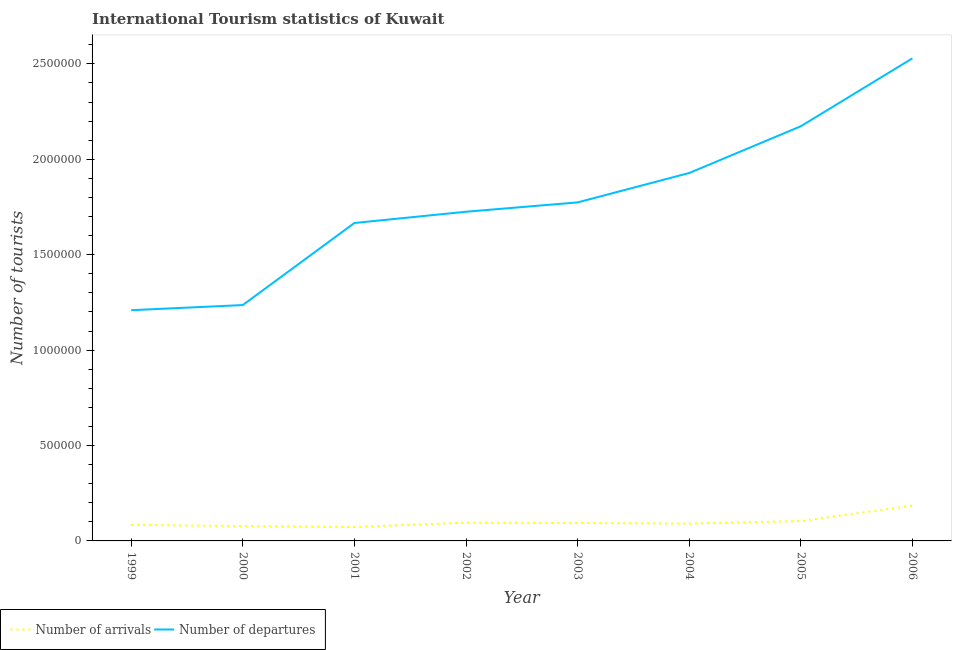How many different coloured lines are there?
Ensure brevity in your answer.  2. Does the line corresponding to number of tourist arrivals intersect with the line corresponding to number of tourist departures?
Your answer should be compact. No. What is the number of tourist arrivals in 1999?
Offer a terse response. 8.40e+04. Across all years, what is the maximum number of tourist departures?
Offer a terse response. 2.53e+06. Across all years, what is the minimum number of tourist departures?
Keep it short and to the point. 1.21e+06. In which year was the number of tourist arrivals maximum?
Provide a short and direct response. 2006. What is the total number of tourist departures in the graph?
Offer a terse response. 1.42e+07. What is the difference between the number of tourist departures in 2002 and that in 2005?
Give a very brief answer. -4.48e+05. What is the difference between the number of tourist arrivals in 2003 and the number of tourist departures in 2000?
Offer a terse response. -1.14e+06. What is the average number of tourist arrivals per year?
Your answer should be very brief. 1.01e+05. In the year 2002, what is the difference between the number of tourist departures and number of tourist arrivals?
Your answer should be compact. 1.63e+06. What is the ratio of the number of tourist departures in 1999 to that in 2005?
Your response must be concise. 0.56. Is the number of tourist departures in 2005 less than that in 2006?
Ensure brevity in your answer.  Yes. What is the difference between the highest and the second highest number of tourist departures?
Provide a succinct answer. 3.56e+05. What is the difference between the highest and the lowest number of tourist departures?
Offer a terse response. 1.32e+06. Is the sum of the number of tourist departures in 2000 and 2006 greater than the maximum number of tourist arrivals across all years?
Provide a succinct answer. Yes. Is the number of tourist departures strictly greater than the number of tourist arrivals over the years?
Make the answer very short. Yes. How many lines are there?
Ensure brevity in your answer.  2. Does the graph contain grids?
Keep it short and to the point. No. Where does the legend appear in the graph?
Ensure brevity in your answer.  Bottom left. What is the title of the graph?
Make the answer very short. International Tourism statistics of Kuwait. Does "Electricity" appear as one of the legend labels in the graph?
Your answer should be compact. No. What is the label or title of the X-axis?
Your answer should be compact. Year. What is the label or title of the Y-axis?
Keep it short and to the point. Number of tourists. What is the Number of tourists in Number of arrivals in 1999?
Provide a short and direct response. 8.40e+04. What is the Number of tourists of Number of departures in 1999?
Ensure brevity in your answer.  1.21e+06. What is the Number of tourists in Number of arrivals in 2000?
Offer a very short reply. 7.80e+04. What is the Number of tourists in Number of departures in 2000?
Provide a short and direct response. 1.24e+06. What is the Number of tourists in Number of arrivals in 2001?
Keep it short and to the point. 7.30e+04. What is the Number of tourists in Number of departures in 2001?
Your response must be concise. 1.67e+06. What is the Number of tourists in Number of arrivals in 2002?
Your answer should be very brief. 9.60e+04. What is the Number of tourists in Number of departures in 2002?
Make the answer very short. 1.72e+06. What is the Number of tourists in Number of arrivals in 2003?
Your answer should be compact. 9.40e+04. What is the Number of tourists in Number of departures in 2003?
Offer a terse response. 1.77e+06. What is the Number of tourists of Number of arrivals in 2004?
Your answer should be compact. 9.10e+04. What is the Number of tourists of Number of departures in 2004?
Make the answer very short. 1.93e+06. What is the Number of tourists in Number of arrivals in 2005?
Ensure brevity in your answer.  1.04e+05. What is the Number of tourists in Number of departures in 2005?
Offer a very short reply. 2.17e+06. What is the Number of tourists in Number of arrivals in 2006?
Your answer should be compact. 1.85e+05. What is the Number of tourists in Number of departures in 2006?
Give a very brief answer. 2.53e+06. Across all years, what is the maximum Number of tourists in Number of arrivals?
Ensure brevity in your answer.  1.85e+05. Across all years, what is the maximum Number of tourists of Number of departures?
Provide a short and direct response. 2.53e+06. Across all years, what is the minimum Number of tourists in Number of arrivals?
Offer a terse response. 7.30e+04. Across all years, what is the minimum Number of tourists of Number of departures?
Ensure brevity in your answer.  1.21e+06. What is the total Number of tourists in Number of arrivals in the graph?
Ensure brevity in your answer.  8.05e+05. What is the total Number of tourists of Number of departures in the graph?
Make the answer very short. 1.42e+07. What is the difference between the Number of tourists of Number of arrivals in 1999 and that in 2000?
Provide a short and direct response. 6000. What is the difference between the Number of tourists of Number of departures in 1999 and that in 2000?
Ensure brevity in your answer.  -2.70e+04. What is the difference between the Number of tourists of Number of arrivals in 1999 and that in 2001?
Keep it short and to the point. 1.10e+04. What is the difference between the Number of tourists in Number of departures in 1999 and that in 2001?
Provide a succinct answer. -4.57e+05. What is the difference between the Number of tourists of Number of arrivals in 1999 and that in 2002?
Make the answer very short. -1.20e+04. What is the difference between the Number of tourists of Number of departures in 1999 and that in 2002?
Make the answer very short. -5.16e+05. What is the difference between the Number of tourists in Number of departures in 1999 and that in 2003?
Your answer should be compact. -5.65e+05. What is the difference between the Number of tourists of Number of arrivals in 1999 and that in 2004?
Offer a very short reply. -7000. What is the difference between the Number of tourists of Number of departures in 1999 and that in 2004?
Your response must be concise. -7.19e+05. What is the difference between the Number of tourists of Number of departures in 1999 and that in 2005?
Your answer should be compact. -9.64e+05. What is the difference between the Number of tourists of Number of arrivals in 1999 and that in 2006?
Offer a very short reply. -1.01e+05. What is the difference between the Number of tourists in Number of departures in 1999 and that in 2006?
Give a very brief answer. -1.32e+06. What is the difference between the Number of tourists of Number of arrivals in 2000 and that in 2001?
Ensure brevity in your answer.  5000. What is the difference between the Number of tourists of Number of departures in 2000 and that in 2001?
Provide a short and direct response. -4.30e+05. What is the difference between the Number of tourists in Number of arrivals in 2000 and that in 2002?
Provide a short and direct response. -1.80e+04. What is the difference between the Number of tourists in Number of departures in 2000 and that in 2002?
Provide a succinct answer. -4.89e+05. What is the difference between the Number of tourists in Number of arrivals in 2000 and that in 2003?
Provide a succinct answer. -1.60e+04. What is the difference between the Number of tourists in Number of departures in 2000 and that in 2003?
Provide a succinct answer. -5.38e+05. What is the difference between the Number of tourists in Number of arrivals in 2000 and that in 2004?
Offer a terse response. -1.30e+04. What is the difference between the Number of tourists in Number of departures in 2000 and that in 2004?
Your answer should be very brief. -6.92e+05. What is the difference between the Number of tourists in Number of arrivals in 2000 and that in 2005?
Offer a terse response. -2.60e+04. What is the difference between the Number of tourists in Number of departures in 2000 and that in 2005?
Make the answer very short. -9.37e+05. What is the difference between the Number of tourists of Number of arrivals in 2000 and that in 2006?
Provide a succinct answer. -1.07e+05. What is the difference between the Number of tourists of Number of departures in 2000 and that in 2006?
Your response must be concise. -1.29e+06. What is the difference between the Number of tourists of Number of arrivals in 2001 and that in 2002?
Ensure brevity in your answer.  -2.30e+04. What is the difference between the Number of tourists in Number of departures in 2001 and that in 2002?
Offer a terse response. -5.90e+04. What is the difference between the Number of tourists in Number of arrivals in 2001 and that in 2003?
Provide a short and direct response. -2.10e+04. What is the difference between the Number of tourists of Number of departures in 2001 and that in 2003?
Offer a very short reply. -1.08e+05. What is the difference between the Number of tourists in Number of arrivals in 2001 and that in 2004?
Offer a terse response. -1.80e+04. What is the difference between the Number of tourists in Number of departures in 2001 and that in 2004?
Offer a very short reply. -2.62e+05. What is the difference between the Number of tourists of Number of arrivals in 2001 and that in 2005?
Make the answer very short. -3.10e+04. What is the difference between the Number of tourists in Number of departures in 2001 and that in 2005?
Keep it short and to the point. -5.07e+05. What is the difference between the Number of tourists in Number of arrivals in 2001 and that in 2006?
Offer a terse response. -1.12e+05. What is the difference between the Number of tourists in Number of departures in 2001 and that in 2006?
Your answer should be compact. -8.63e+05. What is the difference between the Number of tourists of Number of arrivals in 2002 and that in 2003?
Make the answer very short. 2000. What is the difference between the Number of tourists of Number of departures in 2002 and that in 2003?
Offer a very short reply. -4.90e+04. What is the difference between the Number of tourists of Number of departures in 2002 and that in 2004?
Provide a short and direct response. -2.03e+05. What is the difference between the Number of tourists in Number of arrivals in 2002 and that in 2005?
Give a very brief answer. -8000. What is the difference between the Number of tourists of Number of departures in 2002 and that in 2005?
Your answer should be very brief. -4.48e+05. What is the difference between the Number of tourists in Number of arrivals in 2002 and that in 2006?
Your response must be concise. -8.90e+04. What is the difference between the Number of tourists in Number of departures in 2002 and that in 2006?
Keep it short and to the point. -8.04e+05. What is the difference between the Number of tourists of Number of arrivals in 2003 and that in 2004?
Make the answer very short. 3000. What is the difference between the Number of tourists of Number of departures in 2003 and that in 2004?
Offer a very short reply. -1.54e+05. What is the difference between the Number of tourists in Number of departures in 2003 and that in 2005?
Your answer should be very brief. -3.99e+05. What is the difference between the Number of tourists of Number of arrivals in 2003 and that in 2006?
Your response must be concise. -9.10e+04. What is the difference between the Number of tourists of Number of departures in 2003 and that in 2006?
Your answer should be compact. -7.55e+05. What is the difference between the Number of tourists of Number of arrivals in 2004 and that in 2005?
Give a very brief answer. -1.30e+04. What is the difference between the Number of tourists of Number of departures in 2004 and that in 2005?
Your answer should be compact. -2.45e+05. What is the difference between the Number of tourists of Number of arrivals in 2004 and that in 2006?
Give a very brief answer. -9.40e+04. What is the difference between the Number of tourists of Number of departures in 2004 and that in 2006?
Your response must be concise. -6.01e+05. What is the difference between the Number of tourists in Number of arrivals in 2005 and that in 2006?
Give a very brief answer. -8.10e+04. What is the difference between the Number of tourists of Number of departures in 2005 and that in 2006?
Offer a very short reply. -3.56e+05. What is the difference between the Number of tourists of Number of arrivals in 1999 and the Number of tourists of Number of departures in 2000?
Your answer should be very brief. -1.15e+06. What is the difference between the Number of tourists of Number of arrivals in 1999 and the Number of tourists of Number of departures in 2001?
Offer a very short reply. -1.58e+06. What is the difference between the Number of tourists of Number of arrivals in 1999 and the Number of tourists of Number of departures in 2002?
Provide a succinct answer. -1.64e+06. What is the difference between the Number of tourists in Number of arrivals in 1999 and the Number of tourists in Number of departures in 2003?
Ensure brevity in your answer.  -1.69e+06. What is the difference between the Number of tourists in Number of arrivals in 1999 and the Number of tourists in Number of departures in 2004?
Give a very brief answer. -1.84e+06. What is the difference between the Number of tourists in Number of arrivals in 1999 and the Number of tourists in Number of departures in 2005?
Your answer should be compact. -2.09e+06. What is the difference between the Number of tourists in Number of arrivals in 1999 and the Number of tourists in Number of departures in 2006?
Provide a short and direct response. -2.44e+06. What is the difference between the Number of tourists of Number of arrivals in 2000 and the Number of tourists of Number of departures in 2001?
Your answer should be very brief. -1.59e+06. What is the difference between the Number of tourists in Number of arrivals in 2000 and the Number of tourists in Number of departures in 2002?
Offer a terse response. -1.65e+06. What is the difference between the Number of tourists in Number of arrivals in 2000 and the Number of tourists in Number of departures in 2003?
Your answer should be compact. -1.70e+06. What is the difference between the Number of tourists of Number of arrivals in 2000 and the Number of tourists of Number of departures in 2004?
Your answer should be compact. -1.85e+06. What is the difference between the Number of tourists in Number of arrivals in 2000 and the Number of tourists in Number of departures in 2005?
Offer a very short reply. -2.10e+06. What is the difference between the Number of tourists in Number of arrivals in 2000 and the Number of tourists in Number of departures in 2006?
Provide a succinct answer. -2.45e+06. What is the difference between the Number of tourists in Number of arrivals in 2001 and the Number of tourists in Number of departures in 2002?
Your response must be concise. -1.65e+06. What is the difference between the Number of tourists in Number of arrivals in 2001 and the Number of tourists in Number of departures in 2003?
Your answer should be compact. -1.70e+06. What is the difference between the Number of tourists in Number of arrivals in 2001 and the Number of tourists in Number of departures in 2004?
Your answer should be very brief. -1.86e+06. What is the difference between the Number of tourists in Number of arrivals in 2001 and the Number of tourists in Number of departures in 2005?
Give a very brief answer. -2.10e+06. What is the difference between the Number of tourists of Number of arrivals in 2001 and the Number of tourists of Number of departures in 2006?
Offer a very short reply. -2.46e+06. What is the difference between the Number of tourists of Number of arrivals in 2002 and the Number of tourists of Number of departures in 2003?
Offer a terse response. -1.68e+06. What is the difference between the Number of tourists of Number of arrivals in 2002 and the Number of tourists of Number of departures in 2004?
Offer a terse response. -1.83e+06. What is the difference between the Number of tourists in Number of arrivals in 2002 and the Number of tourists in Number of departures in 2005?
Your response must be concise. -2.08e+06. What is the difference between the Number of tourists in Number of arrivals in 2002 and the Number of tourists in Number of departures in 2006?
Offer a terse response. -2.43e+06. What is the difference between the Number of tourists in Number of arrivals in 2003 and the Number of tourists in Number of departures in 2004?
Your response must be concise. -1.83e+06. What is the difference between the Number of tourists in Number of arrivals in 2003 and the Number of tourists in Number of departures in 2005?
Ensure brevity in your answer.  -2.08e+06. What is the difference between the Number of tourists in Number of arrivals in 2003 and the Number of tourists in Number of departures in 2006?
Give a very brief answer. -2.44e+06. What is the difference between the Number of tourists of Number of arrivals in 2004 and the Number of tourists of Number of departures in 2005?
Provide a succinct answer. -2.08e+06. What is the difference between the Number of tourists in Number of arrivals in 2004 and the Number of tourists in Number of departures in 2006?
Ensure brevity in your answer.  -2.44e+06. What is the difference between the Number of tourists of Number of arrivals in 2005 and the Number of tourists of Number of departures in 2006?
Make the answer very short. -2.42e+06. What is the average Number of tourists in Number of arrivals per year?
Offer a terse response. 1.01e+05. What is the average Number of tourists of Number of departures per year?
Keep it short and to the point. 1.78e+06. In the year 1999, what is the difference between the Number of tourists of Number of arrivals and Number of tourists of Number of departures?
Your answer should be very brief. -1.12e+06. In the year 2000, what is the difference between the Number of tourists of Number of arrivals and Number of tourists of Number of departures?
Offer a very short reply. -1.16e+06. In the year 2001, what is the difference between the Number of tourists in Number of arrivals and Number of tourists in Number of departures?
Provide a succinct answer. -1.59e+06. In the year 2002, what is the difference between the Number of tourists of Number of arrivals and Number of tourists of Number of departures?
Ensure brevity in your answer.  -1.63e+06. In the year 2003, what is the difference between the Number of tourists in Number of arrivals and Number of tourists in Number of departures?
Your answer should be compact. -1.68e+06. In the year 2004, what is the difference between the Number of tourists in Number of arrivals and Number of tourists in Number of departures?
Offer a very short reply. -1.84e+06. In the year 2005, what is the difference between the Number of tourists in Number of arrivals and Number of tourists in Number of departures?
Give a very brief answer. -2.07e+06. In the year 2006, what is the difference between the Number of tourists in Number of arrivals and Number of tourists in Number of departures?
Provide a short and direct response. -2.34e+06. What is the ratio of the Number of tourists in Number of arrivals in 1999 to that in 2000?
Provide a short and direct response. 1.08. What is the ratio of the Number of tourists in Number of departures in 1999 to that in 2000?
Offer a terse response. 0.98. What is the ratio of the Number of tourists in Number of arrivals in 1999 to that in 2001?
Offer a very short reply. 1.15. What is the ratio of the Number of tourists of Number of departures in 1999 to that in 2001?
Offer a terse response. 0.73. What is the ratio of the Number of tourists of Number of departures in 1999 to that in 2002?
Your response must be concise. 0.7. What is the ratio of the Number of tourists in Number of arrivals in 1999 to that in 2003?
Provide a succinct answer. 0.89. What is the ratio of the Number of tourists in Number of departures in 1999 to that in 2003?
Ensure brevity in your answer.  0.68. What is the ratio of the Number of tourists of Number of arrivals in 1999 to that in 2004?
Your answer should be compact. 0.92. What is the ratio of the Number of tourists in Number of departures in 1999 to that in 2004?
Keep it short and to the point. 0.63. What is the ratio of the Number of tourists in Number of arrivals in 1999 to that in 2005?
Your answer should be compact. 0.81. What is the ratio of the Number of tourists in Number of departures in 1999 to that in 2005?
Your response must be concise. 0.56. What is the ratio of the Number of tourists in Number of arrivals in 1999 to that in 2006?
Offer a terse response. 0.45. What is the ratio of the Number of tourists of Number of departures in 1999 to that in 2006?
Your answer should be very brief. 0.48. What is the ratio of the Number of tourists in Number of arrivals in 2000 to that in 2001?
Offer a terse response. 1.07. What is the ratio of the Number of tourists in Number of departures in 2000 to that in 2001?
Provide a short and direct response. 0.74. What is the ratio of the Number of tourists of Number of arrivals in 2000 to that in 2002?
Offer a terse response. 0.81. What is the ratio of the Number of tourists in Number of departures in 2000 to that in 2002?
Offer a very short reply. 0.72. What is the ratio of the Number of tourists in Number of arrivals in 2000 to that in 2003?
Offer a very short reply. 0.83. What is the ratio of the Number of tourists in Number of departures in 2000 to that in 2003?
Your answer should be very brief. 0.7. What is the ratio of the Number of tourists of Number of departures in 2000 to that in 2004?
Offer a very short reply. 0.64. What is the ratio of the Number of tourists in Number of arrivals in 2000 to that in 2005?
Ensure brevity in your answer.  0.75. What is the ratio of the Number of tourists in Number of departures in 2000 to that in 2005?
Provide a succinct answer. 0.57. What is the ratio of the Number of tourists of Number of arrivals in 2000 to that in 2006?
Your answer should be compact. 0.42. What is the ratio of the Number of tourists of Number of departures in 2000 to that in 2006?
Ensure brevity in your answer.  0.49. What is the ratio of the Number of tourists of Number of arrivals in 2001 to that in 2002?
Give a very brief answer. 0.76. What is the ratio of the Number of tourists of Number of departures in 2001 to that in 2002?
Ensure brevity in your answer.  0.97. What is the ratio of the Number of tourists in Number of arrivals in 2001 to that in 2003?
Give a very brief answer. 0.78. What is the ratio of the Number of tourists in Number of departures in 2001 to that in 2003?
Keep it short and to the point. 0.94. What is the ratio of the Number of tourists in Number of arrivals in 2001 to that in 2004?
Ensure brevity in your answer.  0.8. What is the ratio of the Number of tourists in Number of departures in 2001 to that in 2004?
Ensure brevity in your answer.  0.86. What is the ratio of the Number of tourists of Number of arrivals in 2001 to that in 2005?
Provide a succinct answer. 0.7. What is the ratio of the Number of tourists in Number of departures in 2001 to that in 2005?
Ensure brevity in your answer.  0.77. What is the ratio of the Number of tourists in Number of arrivals in 2001 to that in 2006?
Keep it short and to the point. 0.39. What is the ratio of the Number of tourists in Number of departures in 2001 to that in 2006?
Make the answer very short. 0.66. What is the ratio of the Number of tourists of Number of arrivals in 2002 to that in 2003?
Provide a succinct answer. 1.02. What is the ratio of the Number of tourists of Number of departures in 2002 to that in 2003?
Offer a very short reply. 0.97. What is the ratio of the Number of tourists of Number of arrivals in 2002 to that in 2004?
Keep it short and to the point. 1.05. What is the ratio of the Number of tourists of Number of departures in 2002 to that in 2004?
Make the answer very short. 0.89. What is the ratio of the Number of tourists of Number of departures in 2002 to that in 2005?
Make the answer very short. 0.79. What is the ratio of the Number of tourists of Number of arrivals in 2002 to that in 2006?
Your answer should be compact. 0.52. What is the ratio of the Number of tourists in Number of departures in 2002 to that in 2006?
Your answer should be very brief. 0.68. What is the ratio of the Number of tourists in Number of arrivals in 2003 to that in 2004?
Provide a short and direct response. 1.03. What is the ratio of the Number of tourists in Number of departures in 2003 to that in 2004?
Keep it short and to the point. 0.92. What is the ratio of the Number of tourists of Number of arrivals in 2003 to that in 2005?
Make the answer very short. 0.9. What is the ratio of the Number of tourists of Number of departures in 2003 to that in 2005?
Make the answer very short. 0.82. What is the ratio of the Number of tourists in Number of arrivals in 2003 to that in 2006?
Give a very brief answer. 0.51. What is the ratio of the Number of tourists in Number of departures in 2003 to that in 2006?
Offer a terse response. 0.7. What is the ratio of the Number of tourists in Number of arrivals in 2004 to that in 2005?
Offer a terse response. 0.88. What is the ratio of the Number of tourists in Number of departures in 2004 to that in 2005?
Your answer should be compact. 0.89. What is the ratio of the Number of tourists of Number of arrivals in 2004 to that in 2006?
Your response must be concise. 0.49. What is the ratio of the Number of tourists of Number of departures in 2004 to that in 2006?
Your response must be concise. 0.76. What is the ratio of the Number of tourists of Number of arrivals in 2005 to that in 2006?
Give a very brief answer. 0.56. What is the ratio of the Number of tourists in Number of departures in 2005 to that in 2006?
Make the answer very short. 0.86. What is the difference between the highest and the second highest Number of tourists of Number of arrivals?
Ensure brevity in your answer.  8.10e+04. What is the difference between the highest and the second highest Number of tourists of Number of departures?
Provide a succinct answer. 3.56e+05. What is the difference between the highest and the lowest Number of tourists of Number of arrivals?
Ensure brevity in your answer.  1.12e+05. What is the difference between the highest and the lowest Number of tourists of Number of departures?
Keep it short and to the point. 1.32e+06. 